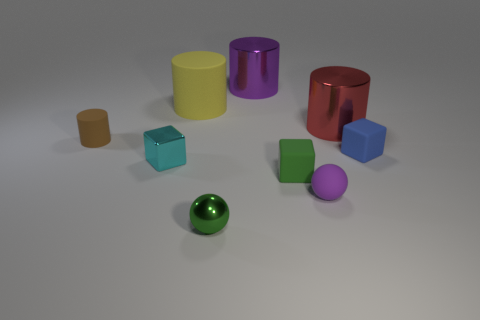What is the color of the cylinder that is the same size as the blue rubber block?
Give a very brief answer. Brown. Is there a small metallic object that is to the right of the ball right of the green ball?
Your answer should be very brief. No. How many cubes are either blue rubber objects or small green matte things?
Your answer should be compact. 2. There is a yellow object behind the tiny sphere to the left of the large shiny cylinder to the left of the tiny green rubber thing; what is its size?
Your answer should be very brief. Large. Are there any cubes behind the large matte cylinder?
Keep it short and to the point. No. There is a tiny matte object that is the same color as the tiny shiny ball; what shape is it?
Your answer should be compact. Cube. What number of things are small things that are behind the small green metal sphere or small green metallic balls?
Offer a terse response. 6. The blue block that is made of the same material as the small green block is what size?
Offer a very short reply. Small. Is the size of the purple rubber sphere the same as the cube that is behind the small cyan shiny cube?
Your answer should be compact. Yes. There is a small rubber object that is behind the cyan cube and on the left side of the blue cube; what color is it?
Your answer should be compact. Brown. 